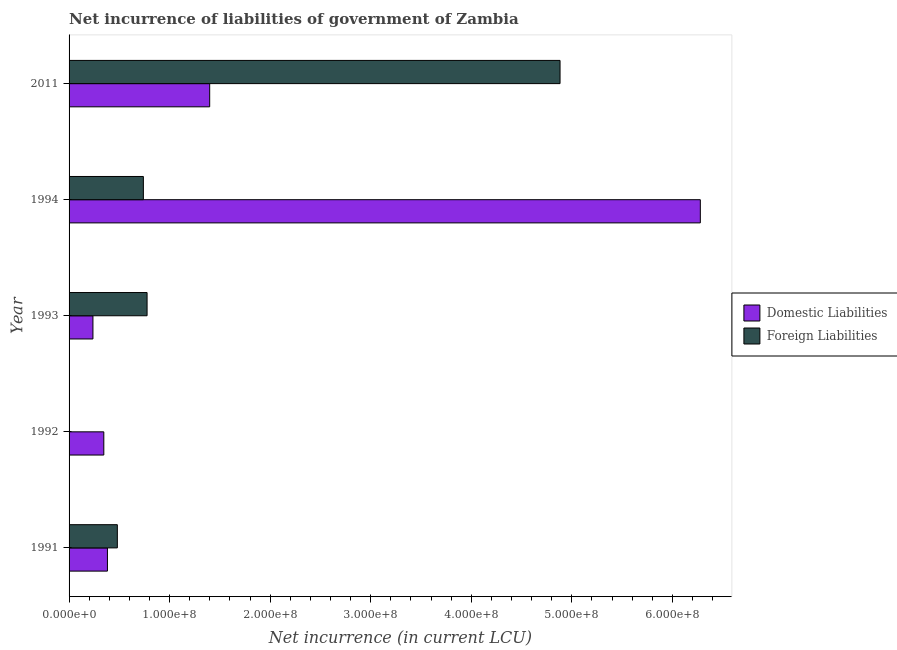How many different coloured bars are there?
Your answer should be compact. 2. How many groups of bars are there?
Your answer should be very brief. 5. Are the number of bars per tick equal to the number of legend labels?
Provide a succinct answer. Yes. Are the number of bars on each tick of the Y-axis equal?
Keep it short and to the point. Yes. In how many cases, is the number of bars for a given year not equal to the number of legend labels?
Offer a very short reply. 0. What is the net incurrence of foreign liabilities in 2011?
Make the answer very short. 4.88e+08. Across all years, what is the maximum net incurrence of domestic liabilities?
Keep it short and to the point. 6.28e+08. Across all years, what is the minimum net incurrence of foreign liabilities?
Offer a very short reply. 9.39e+04. What is the total net incurrence of domestic liabilities in the graph?
Provide a short and direct response. 8.64e+08. What is the difference between the net incurrence of foreign liabilities in 1993 and that in 2011?
Offer a very short reply. -4.11e+08. What is the difference between the net incurrence of foreign liabilities in 1994 and the net incurrence of domestic liabilities in 1993?
Your response must be concise. 5.02e+07. What is the average net incurrence of foreign liabilities per year?
Offer a terse response. 1.38e+08. In the year 1992, what is the difference between the net incurrence of foreign liabilities and net incurrence of domestic liabilities?
Keep it short and to the point. -3.45e+07. In how many years, is the net incurrence of foreign liabilities greater than 400000000 LCU?
Keep it short and to the point. 1. Is the net incurrence of foreign liabilities in 1993 less than that in 1994?
Give a very brief answer. No. What is the difference between the highest and the second highest net incurrence of foreign liabilities?
Offer a very short reply. 4.11e+08. What is the difference between the highest and the lowest net incurrence of foreign liabilities?
Keep it short and to the point. 4.88e+08. In how many years, is the net incurrence of domestic liabilities greater than the average net incurrence of domestic liabilities taken over all years?
Your response must be concise. 1. What does the 1st bar from the top in 1994 represents?
Your answer should be compact. Foreign Liabilities. What does the 1st bar from the bottom in 1991 represents?
Your answer should be very brief. Domestic Liabilities. How many bars are there?
Give a very brief answer. 10. How many years are there in the graph?
Keep it short and to the point. 5. What is the difference between two consecutive major ticks on the X-axis?
Give a very brief answer. 1.00e+08. Are the values on the major ticks of X-axis written in scientific E-notation?
Keep it short and to the point. Yes. Does the graph contain grids?
Give a very brief answer. No. Where does the legend appear in the graph?
Provide a short and direct response. Center right. How many legend labels are there?
Offer a very short reply. 2. What is the title of the graph?
Ensure brevity in your answer.  Net incurrence of liabilities of government of Zambia. Does "Services" appear as one of the legend labels in the graph?
Your answer should be very brief. No. What is the label or title of the X-axis?
Keep it short and to the point. Net incurrence (in current LCU). What is the label or title of the Y-axis?
Make the answer very short. Year. What is the Net incurrence (in current LCU) in Domestic Liabilities in 1991?
Make the answer very short. 3.82e+07. What is the Net incurrence (in current LCU) of Foreign Liabilities in 1991?
Offer a terse response. 4.80e+07. What is the Net incurrence (in current LCU) in Domestic Liabilities in 1992?
Your answer should be very brief. 3.46e+07. What is the Net incurrence (in current LCU) of Foreign Liabilities in 1992?
Provide a succinct answer. 9.39e+04. What is the Net incurrence (in current LCU) of Domestic Liabilities in 1993?
Ensure brevity in your answer.  2.37e+07. What is the Net incurrence (in current LCU) in Foreign Liabilities in 1993?
Make the answer very short. 7.76e+07. What is the Net incurrence (in current LCU) of Domestic Liabilities in 1994?
Offer a very short reply. 6.28e+08. What is the Net incurrence (in current LCU) of Foreign Liabilities in 1994?
Provide a succinct answer. 7.39e+07. What is the Net incurrence (in current LCU) in Domestic Liabilities in 2011?
Provide a succinct answer. 1.40e+08. What is the Net incurrence (in current LCU) in Foreign Liabilities in 2011?
Give a very brief answer. 4.88e+08. Across all years, what is the maximum Net incurrence (in current LCU) of Domestic Liabilities?
Your response must be concise. 6.28e+08. Across all years, what is the maximum Net incurrence (in current LCU) in Foreign Liabilities?
Give a very brief answer. 4.88e+08. Across all years, what is the minimum Net incurrence (in current LCU) in Domestic Liabilities?
Provide a succinct answer. 2.37e+07. Across all years, what is the minimum Net incurrence (in current LCU) of Foreign Liabilities?
Ensure brevity in your answer.  9.39e+04. What is the total Net incurrence (in current LCU) of Domestic Liabilities in the graph?
Ensure brevity in your answer.  8.64e+08. What is the total Net incurrence (in current LCU) of Foreign Liabilities in the graph?
Make the answer very short. 6.88e+08. What is the difference between the Net incurrence (in current LCU) in Domestic Liabilities in 1991 and that in 1992?
Ensure brevity in your answer.  3.61e+06. What is the difference between the Net incurrence (in current LCU) of Foreign Liabilities in 1991 and that in 1992?
Ensure brevity in your answer.  4.79e+07. What is the difference between the Net incurrence (in current LCU) of Domestic Liabilities in 1991 and that in 1993?
Make the answer very short. 1.44e+07. What is the difference between the Net incurrence (in current LCU) in Foreign Liabilities in 1991 and that in 1993?
Ensure brevity in your answer.  -2.96e+07. What is the difference between the Net incurrence (in current LCU) in Domestic Liabilities in 1991 and that in 1994?
Your response must be concise. -5.90e+08. What is the difference between the Net incurrence (in current LCU) of Foreign Liabilities in 1991 and that in 1994?
Make the answer very short. -2.59e+07. What is the difference between the Net incurrence (in current LCU) of Domestic Liabilities in 1991 and that in 2011?
Offer a terse response. -1.02e+08. What is the difference between the Net incurrence (in current LCU) in Foreign Liabilities in 1991 and that in 2011?
Offer a very short reply. -4.40e+08. What is the difference between the Net incurrence (in current LCU) in Domestic Liabilities in 1992 and that in 1993?
Your answer should be compact. 1.08e+07. What is the difference between the Net incurrence (in current LCU) of Foreign Liabilities in 1992 and that in 1993?
Your response must be concise. -7.75e+07. What is the difference between the Net incurrence (in current LCU) in Domestic Liabilities in 1992 and that in 1994?
Keep it short and to the point. -5.93e+08. What is the difference between the Net incurrence (in current LCU) of Foreign Liabilities in 1992 and that in 1994?
Give a very brief answer. -7.38e+07. What is the difference between the Net incurrence (in current LCU) in Domestic Liabilities in 1992 and that in 2011?
Provide a succinct answer. -1.05e+08. What is the difference between the Net incurrence (in current LCU) of Foreign Liabilities in 1992 and that in 2011?
Make the answer very short. -4.88e+08. What is the difference between the Net incurrence (in current LCU) of Domestic Liabilities in 1993 and that in 1994?
Your response must be concise. -6.04e+08. What is the difference between the Net incurrence (in current LCU) of Foreign Liabilities in 1993 and that in 1994?
Your answer should be very brief. 3.68e+06. What is the difference between the Net incurrence (in current LCU) in Domestic Liabilities in 1993 and that in 2011?
Provide a short and direct response. -1.16e+08. What is the difference between the Net incurrence (in current LCU) of Foreign Liabilities in 1993 and that in 2011?
Provide a short and direct response. -4.11e+08. What is the difference between the Net incurrence (in current LCU) in Domestic Liabilities in 1994 and that in 2011?
Your answer should be very brief. 4.88e+08. What is the difference between the Net incurrence (in current LCU) in Foreign Liabilities in 1994 and that in 2011?
Provide a succinct answer. -4.14e+08. What is the difference between the Net incurrence (in current LCU) of Domestic Liabilities in 1991 and the Net incurrence (in current LCU) of Foreign Liabilities in 1992?
Provide a succinct answer. 3.81e+07. What is the difference between the Net incurrence (in current LCU) of Domestic Liabilities in 1991 and the Net incurrence (in current LCU) of Foreign Liabilities in 1993?
Ensure brevity in your answer.  -3.94e+07. What is the difference between the Net incurrence (in current LCU) in Domestic Liabilities in 1991 and the Net incurrence (in current LCU) in Foreign Liabilities in 1994?
Offer a very short reply. -3.57e+07. What is the difference between the Net incurrence (in current LCU) of Domestic Liabilities in 1991 and the Net incurrence (in current LCU) of Foreign Liabilities in 2011?
Make the answer very short. -4.50e+08. What is the difference between the Net incurrence (in current LCU) of Domestic Liabilities in 1992 and the Net incurrence (in current LCU) of Foreign Liabilities in 1993?
Your response must be concise. -4.30e+07. What is the difference between the Net incurrence (in current LCU) in Domestic Liabilities in 1992 and the Net incurrence (in current LCU) in Foreign Liabilities in 1994?
Your answer should be very brief. -3.93e+07. What is the difference between the Net incurrence (in current LCU) of Domestic Liabilities in 1992 and the Net incurrence (in current LCU) of Foreign Liabilities in 2011?
Your response must be concise. -4.54e+08. What is the difference between the Net incurrence (in current LCU) in Domestic Liabilities in 1993 and the Net incurrence (in current LCU) in Foreign Liabilities in 1994?
Your answer should be very brief. -5.02e+07. What is the difference between the Net incurrence (in current LCU) in Domestic Liabilities in 1993 and the Net incurrence (in current LCU) in Foreign Liabilities in 2011?
Your answer should be compact. -4.65e+08. What is the difference between the Net incurrence (in current LCU) of Domestic Liabilities in 1994 and the Net incurrence (in current LCU) of Foreign Liabilities in 2011?
Keep it short and to the point. 1.40e+08. What is the average Net incurrence (in current LCU) of Domestic Liabilities per year?
Give a very brief answer. 1.73e+08. What is the average Net incurrence (in current LCU) of Foreign Liabilities per year?
Your response must be concise. 1.38e+08. In the year 1991, what is the difference between the Net incurrence (in current LCU) in Domestic Liabilities and Net incurrence (in current LCU) in Foreign Liabilities?
Your answer should be very brief. -9.85e+06. In the year 1992, what is the difference between the Net incurrence (in current LCU) of Domestic Liabilities and Net incurrence (in current LCU) of Foreign Liabilities?
Your answer should be compact. 3.45e+07. In the year 1993, what is the difference between the Net incurrence (in current LCU) of Domestic Liabilities and Net incurrence (in current LCU) of Foreign Liabilities?
Your response must be concise. -5.38e+07. In the year 1994, what is the difference between the Net incurrence (in current LCU) of Domestic Liabilities and Net incurrence (in current LCU) of Foreign Liabilities?
Give a very brief answer. 5.54e+08. In the year 2011, what is the difference between the Net incurrence (in current LCU) in Domestic Liabilities and Net incurrence (in current LCU) in Foreign Liabilities?
Keep it short and to the point. -3.48e+08. What is the ratio of the Net incurrence (in current LCU) in Domestic Liabilities in 1991 to that in 1992?
Offer a very short reply. 1.1. What is the ratio of the Net incurrence (in current LCU) of Foreign Liabilities in 1991 to that in 1992?
Your answer should be very brief. 511.33. What is the ratio of the Net incurrence (in current LCU) of Domestic Liabilities in 1991 to that in 1993?
Your answer should be compact. 1.61. What is the ratio of the Net incurrence (in current LCU) of Foreign Liabilities in 1991 to that in 1993?
Provide a succinct answer. 0.62. What is the ratio of the Net incurrence (in current LCU) of Domestic Liabilities in 1991 to that in 1994?
Your answer should be compact. 0.06. What is the ratio of the Net incurrence (in current LCU) of Foreign Liabilities in 1991 to that in 1994?
Your answer should be compact. 0.65. What is the ratio of the Net incurrence (in current LCU) of Domestic Liabilities in 1991 to that in 2011?
Offer a very short reply. 0.27. What is the ratio of the Net incurrence (in current LCU) in Foreign Liabilities in 1991 to that in 2011?
Your answer should be compact. 0.1. What is the ratio of the Net incurrence (in current LCU) of Domestic Liabilities in 1992 to that in 1993?
Keep it short and to the point. 1.46. What is the ratio of the Net incurrence (in current LCU) in Foreign Liabilities in 1992 to that in 1993?
Your answer should be very brief. 0. What is the ratio of the Net incurrence (in current LCU) of Domestic Liabilities in 1992 to that in 1994?
Your answer should be very brief. 0.06. What is the ratio of the Net incurrence (in current LCU) of Foreign Liabilities in 1992 to that in 1994?
Keep it short and to the point. 0. What is the ratio of the Net incurrence (in current LCU) of Domestic Liabilities in 1992 to that in 2011?
Your response must be concise. 0.25. What is the ratio of the Net incurrence (in current LCU) in Foreign Liabilities in 1992 to that in 2011?
Make the answer very short. 0. What is the ratio of the Net incurrence (in current LCU) of Domestic Liabilities in 1993 to that in 1994?
Ensure brevity in your answer.  0.04. What is the ratio of the Net incurrence (in current LCU) of Foreign Liabilities in 1993 to that in 1994?
Your answer should be compact. 1.05. What is the ratio of the Net incurrence (in current LCU) of Domestic Liabilities in 1993 to that in 2011?
Make the answer very short. 0.17. What is the ratio of the Net incurrence (in current LCU) of Foreign Liabilities in 1993 to that in 2011?
Your answer should be compact. 0.16. What is the ratio of the Net incurrence (in current LCU) in Domestic Liabilities in 1994 to that in 2011?
Your answer should be very brief. 4.49. What is the ratio of the Net incurrence (in current LCU) of Foreign Liabilities in 1994 to that in 2011?
Your response must be concise. 0.15. What is the difference between the highest and the second highest Net incurrence (in current LCU) in Domestic Liabilities?
Give a very brief answer. 4.88e+08. What is the difference between the highest and the second highest Net incurrence (in current LCU) of Foreign Liabilities?
Make the answer very short. 4.11e+08. What is the difference between the highest and the lowest Net incurrence (in current LCU) in Domestic Liabilities?
Provide a succinct answer. 6.04e+08. What is the difference between the highest and the lowest Net incurrence (in current LCU) of Foreign Liabilities?
Give a very brief answer. 4.88e+08. 